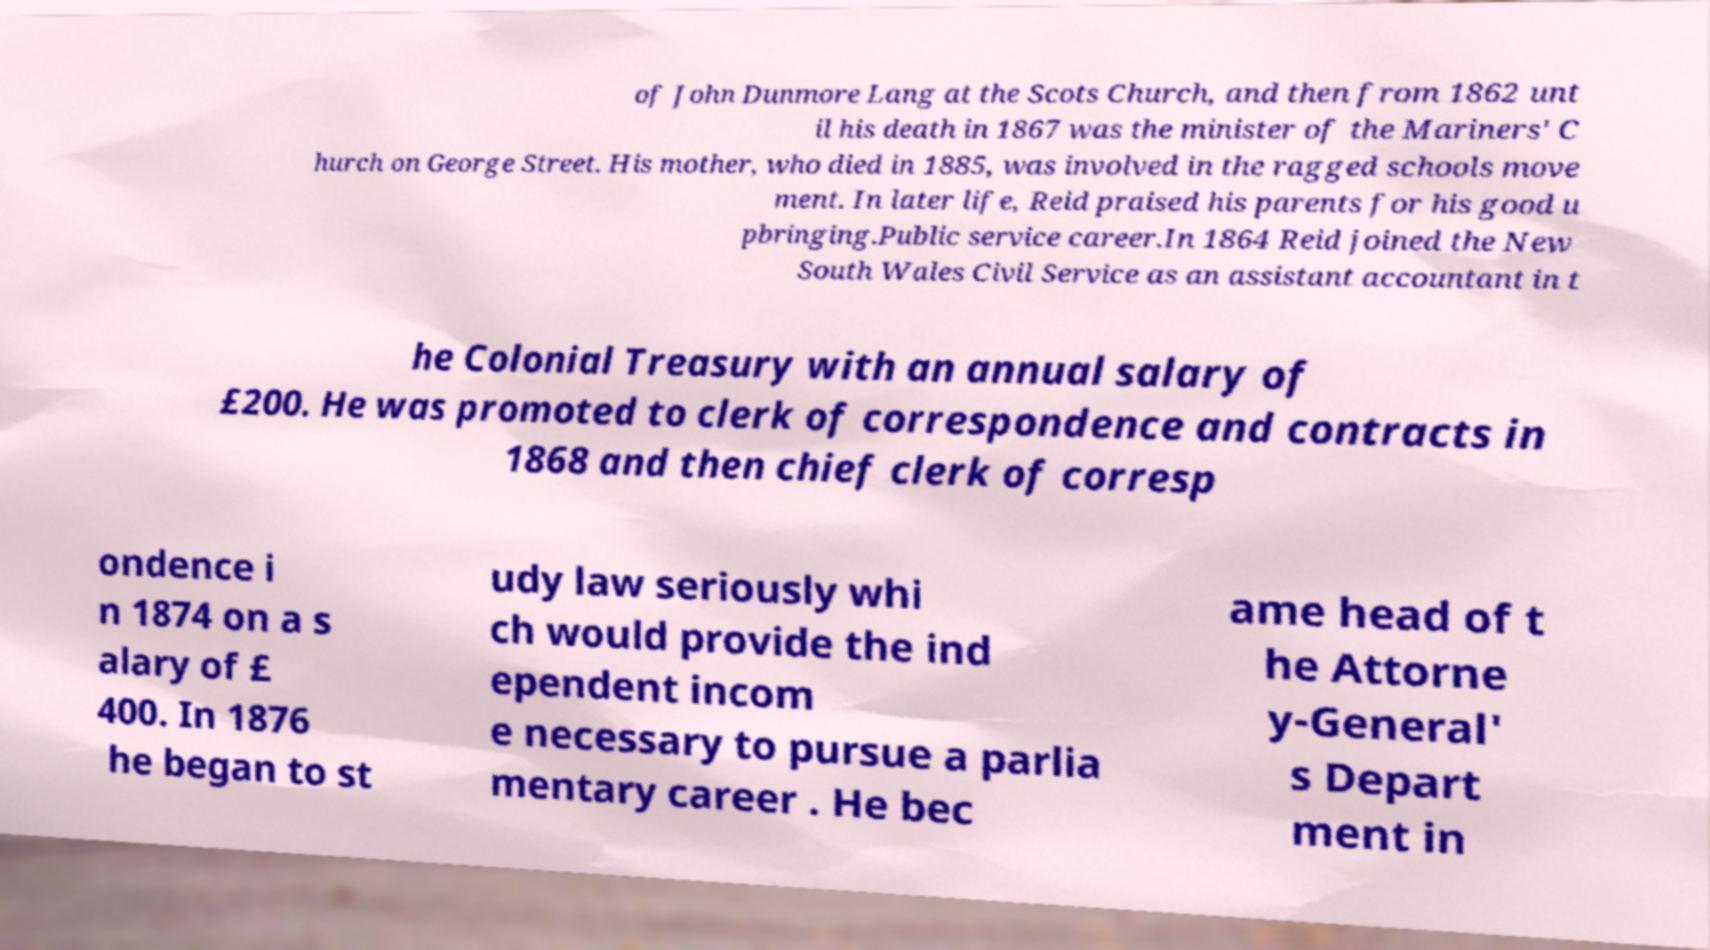There's text embedded in this image that I need extracted. Can you transcribe it verbatim? of John Dunmore Lang at the Scots Church, and then from 1862 unt il his death in 1867 was the minister of the Mariners' C hurch on George Street. His mother, who died in 1885, was involved in the ragged schools move ment. In later life, Reid praised his parents for his good u pbringing.Public service career.In 1864 Reid joined the New South Wales Civil Service as an assistant accountant in t he Colonial Treasury with an annual salary of £200. He was promoted to clerk of correspondence and contracts in 1868 and then chief clerk of corresp ondence i n 1874 on a s alary of £ 400. In 1876 he began to st udy law seriously whi ch would provide the ind ependent incom e necessary to pursue a parlia mentary career . He bec ame head of t he Attorne y-General' s Depart ment in 